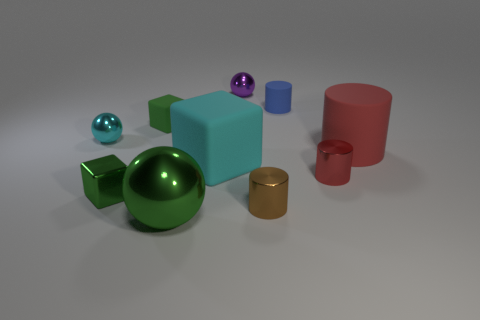What number of other things are there of the same material as the brown cylinder
Your answer should be compact. 5. What is the material of the cylinder that is on the left side of the small blue object to the right of the purple metal thing?
Your answer should be very brief. Metal. The other big ball that is the same material as the cyan sphere is what color?
Offer a very short reply. Green. What shape is the tiny shiny thing that is the same color as the large cylinder?
Give a very brief answer. Cylinder. There is a green matte cube that is behind the small cyan metallic sphere; does it have the same size as the object that is in front of the brown shiny cylinder?
Your answer should be compact. No. How many balls are either large red shiny objects or red rubber objects?
Provide a succinct answer. 0. Do the small sphere to the left of the green ball and the blue cylinder have the same material?
Keep it short and to the point. No. What number of other things are there of the same size as the brown metal object?
Offer a very short reply. 6. What number of large things are red cylinders or blue metallic cubes?
Your response must be concise. 1. Is the color of the big cylinder the same as the large sphere?
Ensure brevity in your answer.  No. 